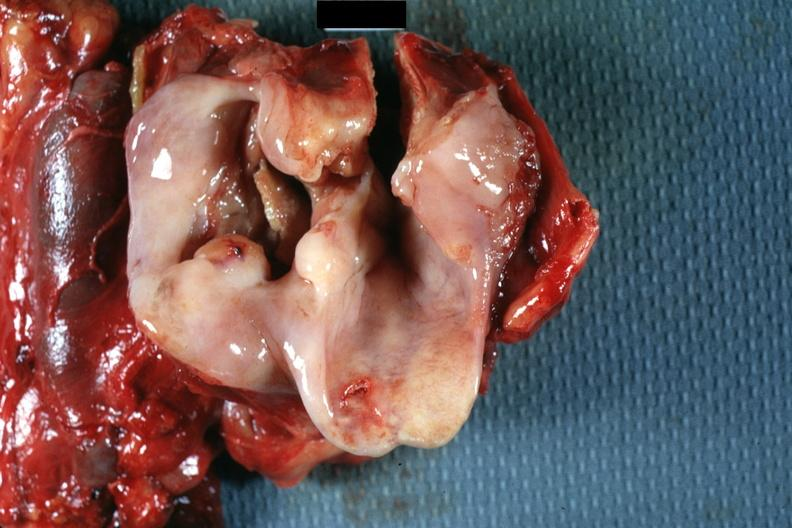does this image show large ulcerative lesion in pyriform sinus natural color?
Answer the question using a single word or phrase. Yes 